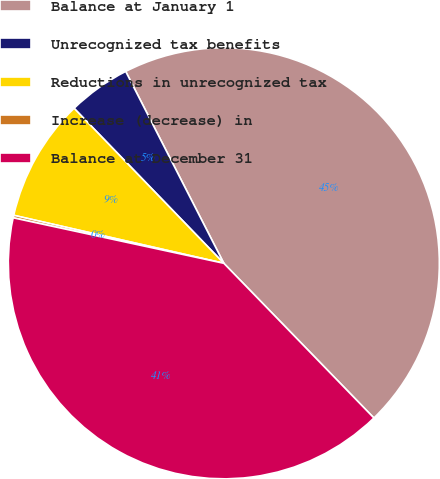Convert chart. <chart><loc_0><loc_0><loc_500><loc_500><pie_chart><fcel>Balance at January 1<fcel>Unrecognized tax benefits<fcel>Reductions in unrecognized tax<fcel>Increase (decrease) in<fcel>Balance at December 31<nl><fcel>45.27%<fcel>4.7%<fcel>9.2%<fcel>0.19%<fcel>40.65%<nl></chart> 